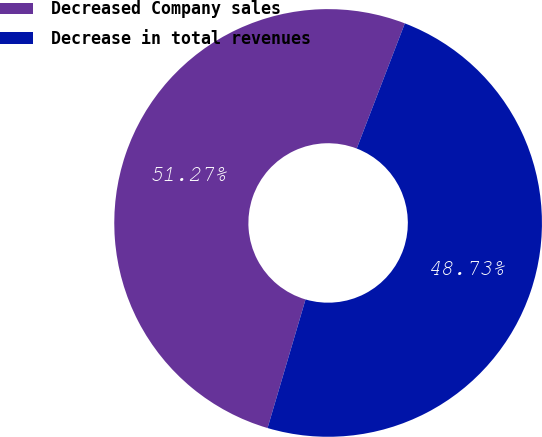Convert chart to OTSL. <chart><loc_0><loc_0><loc_500><loc_500><pie_chart><fcel>Decreased Company sales<fcel>Decrease in total revenues<nl><fcel>51.27%<fcel>48.73%<nl></chart> 